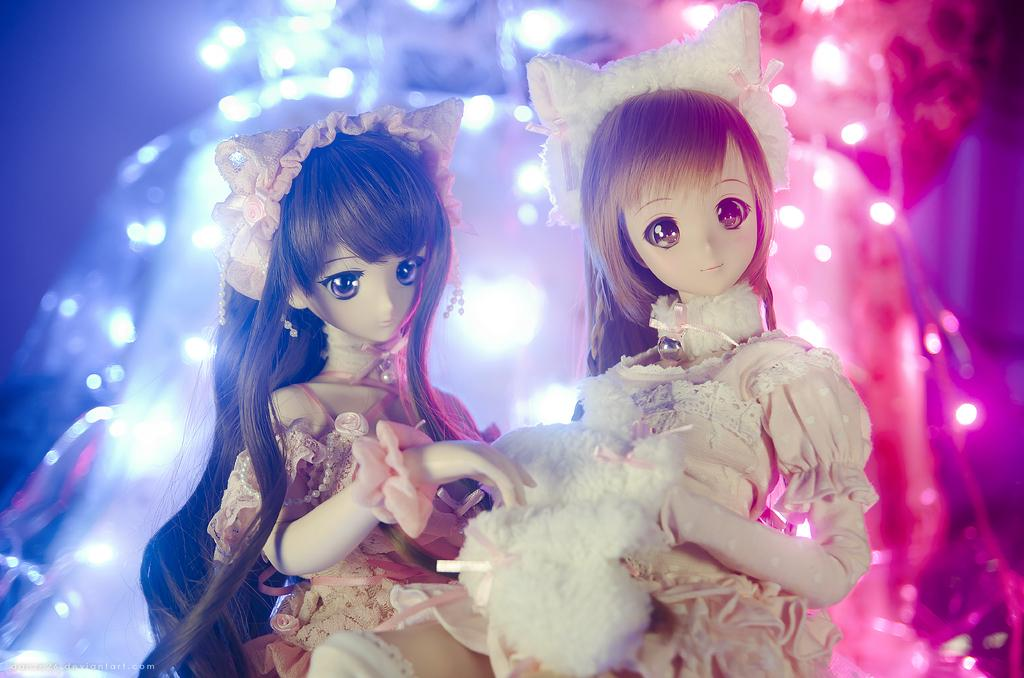What is located in the center of the image? There are dolls in the center of the image. What can be seen in the background of the image? There are lights in the background of the image. What type of berry is being used to decorate the dolls in the image? There are no berries present in the image, and the dolls are not being decorated with any berries. 